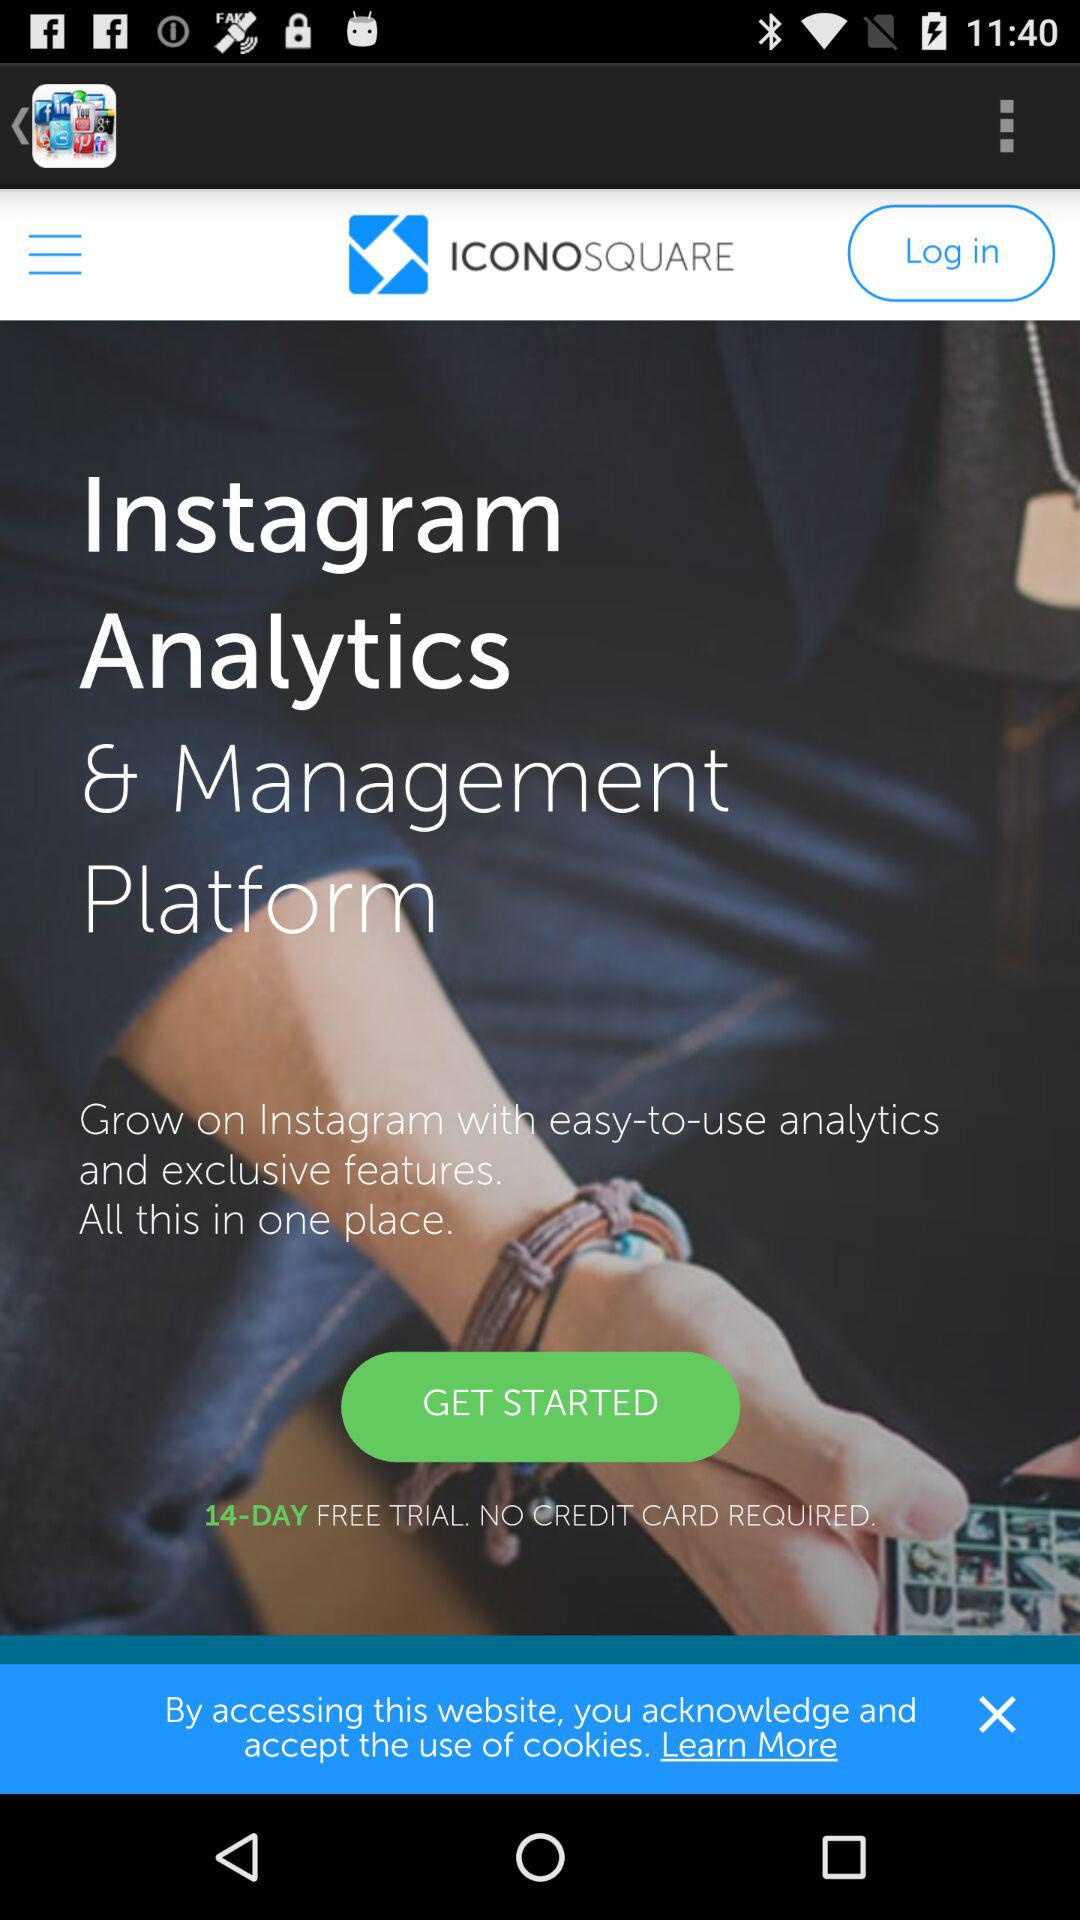What is the name of the application? The name of the application is "ICONOSQUARE". 